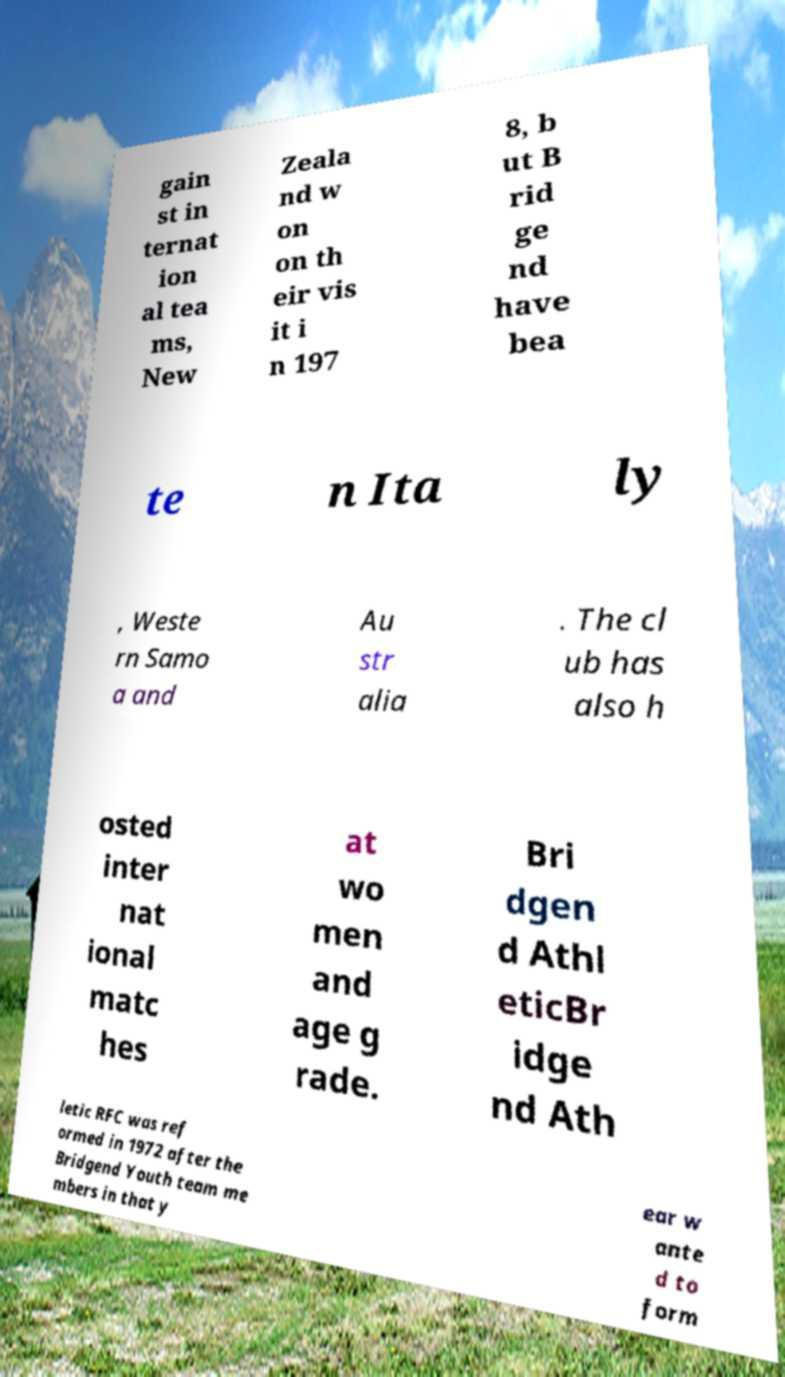I need the written content from this picture converted into text. Can you do that? gain st in ternat ion al tea ms, New Zeala nd w on on th eir vis it i n 197 8, b ut B rid ge nd have bea te n Ita ly , Weste rn Samo a and Au str alia . The cl ub has also h osted inter nat ional matc hes at wo men and age g rade. Bri dgen d Athl eticBr idge nd Ath letic RFC was ref ormed in 1972 after the Bridgend Youth team me mbers in that y ear w ante d to form 